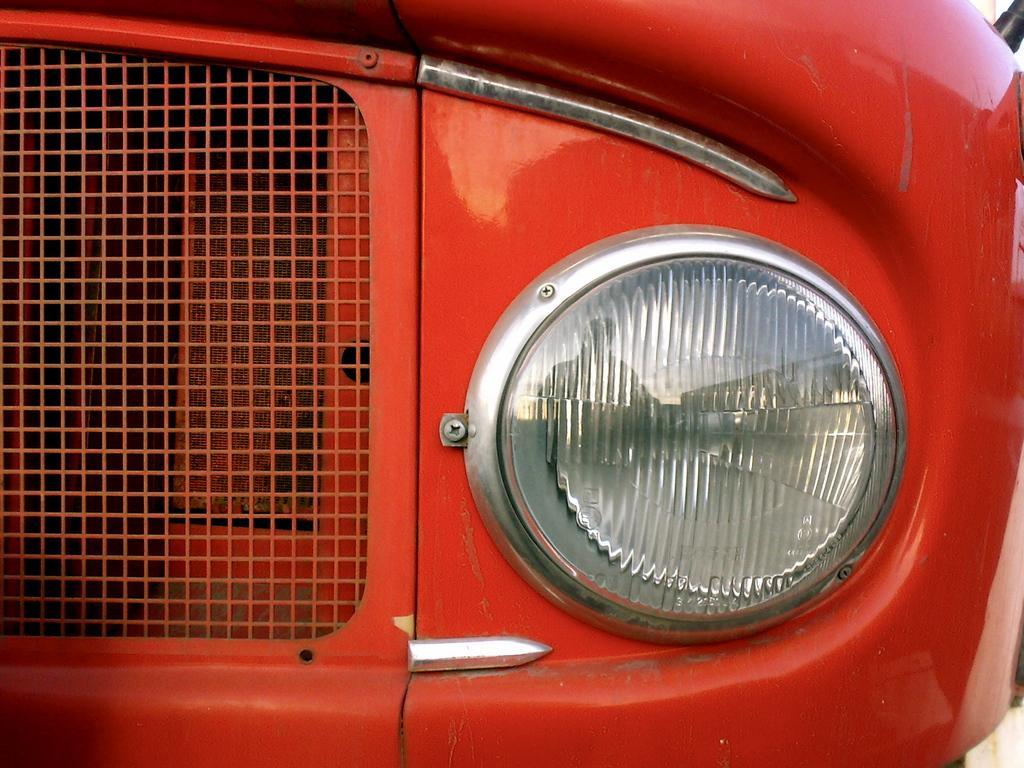Please provide a concise description of this image. In the foreground I can see a vehicle. This image is taken may be during a day. 